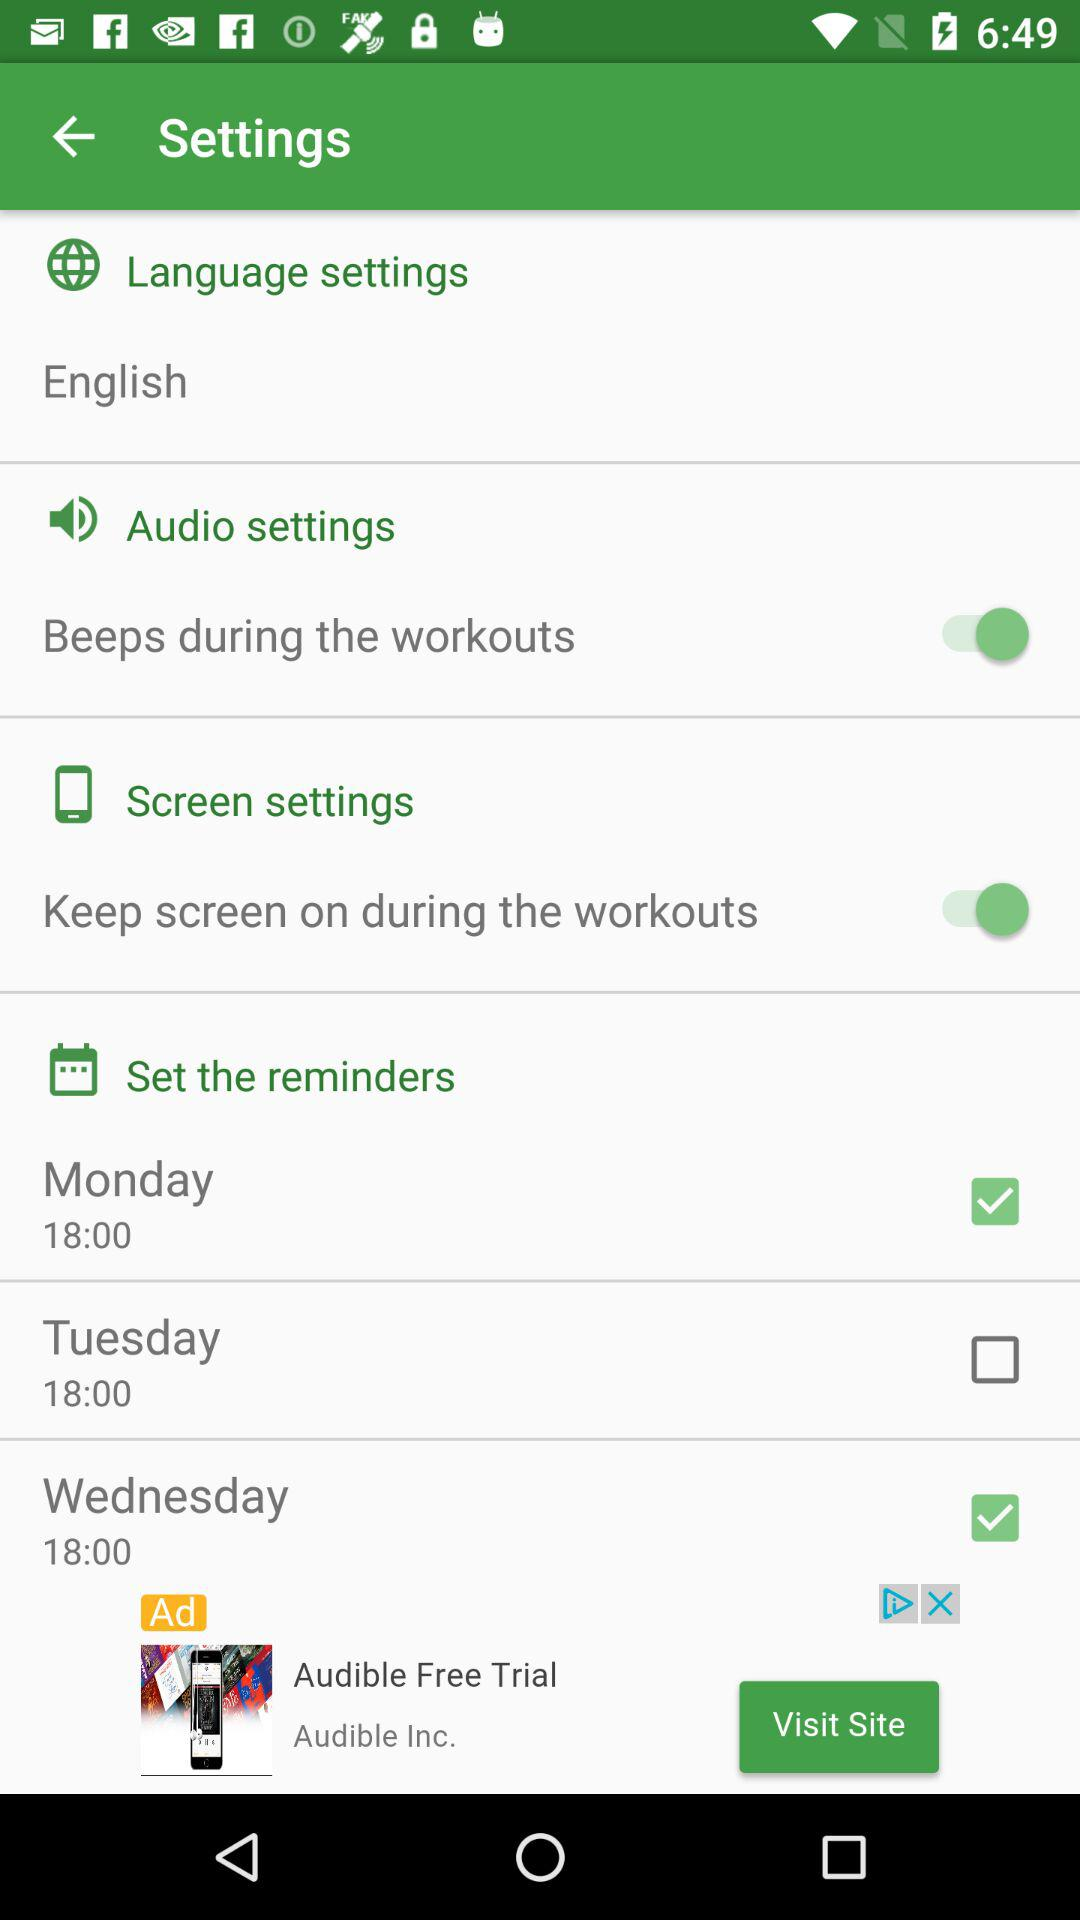What is the set time for the reminder on Monday? The set time for the reminder on Monday is 18:00. 